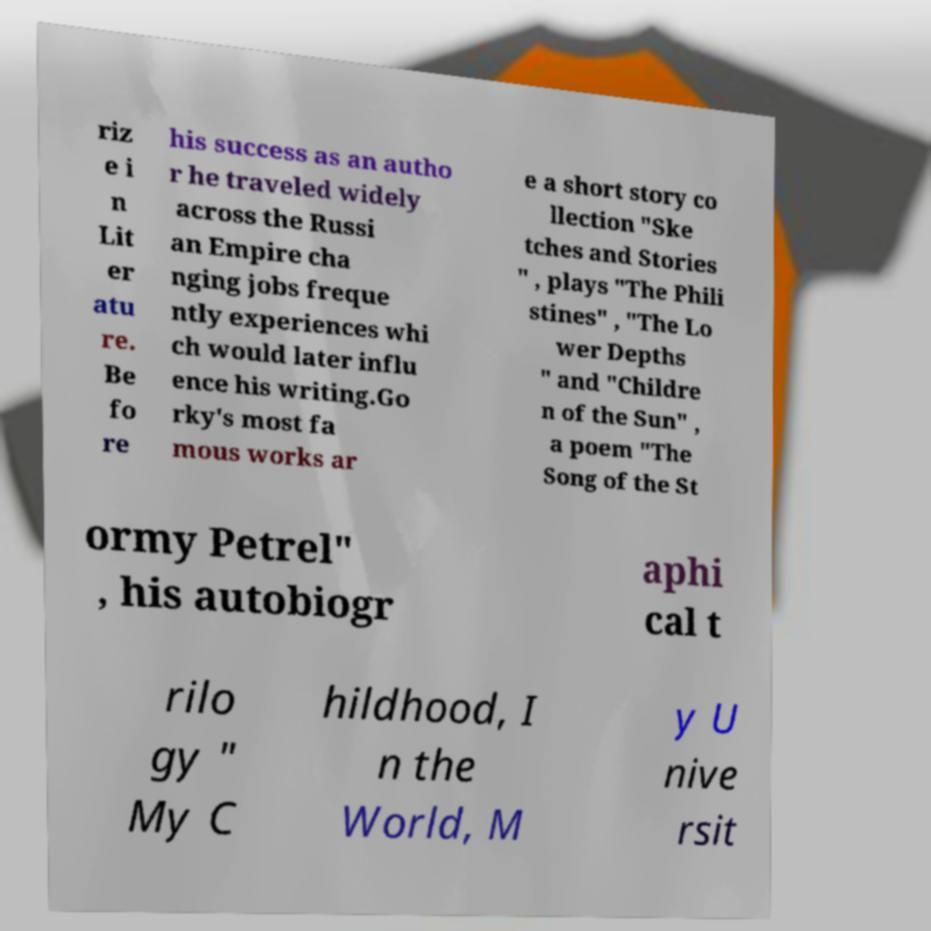What messages or text are displayed in this image? I need them in a readable, typed format. riz e i n Lit er atu re. Be fo re his success as an autho r he traveled widely across the Russi an Empire cha nging jobs freque ntly experiences whi ch would later influ ence his writing.Go rky's most fa mous works ar e a short story co llection "Ske tches and Stories " , plays "The Phili stines" , "The Lo wer Depths " and "Childre n of the Sun" , a poem "The Song of the St ormy Petrel" , his autobiogr aphi cal t rilo gy " My C hildhood, I n the World, M y U nive rsit 